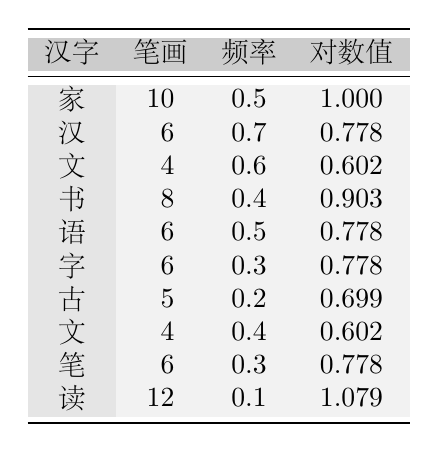What is the stroke count for the character "家"? The table lists the character "家" with a stroke count of 10 in the corresponding row.
Answer: 10 How many characters have a stroke count of 6? By examining the table, the characters "汉," "语," "字," and "笔" have a stroke count of 6. This makes a total of 4 characters.
Answer: 4 Is the frequency of the character "书" greater than 0.5? The table indicates that the frequency for "书" is 0.4, which is less than 0.5.
Answer: No What is the character with the highest stroke count? Comparing the stroke counts across the table, "读" has the highest stroke count of 12.
Answer: 读 What is the average stroke count of the characters listed in the table? To find the average, we sum all stroke counts: 10 + 6 + 4 + 8 + 6 + 6 + 5 + 4 + 6 + 12 = 57. There are 10 characters, so the average is 57 / 10 = 5.7.
Answer: 5.7 Which character has the lowest frequency, and what is that frequency? By reviewing the frequencies in the table, "读" holds the lowest frequency at 0.1.
Answer: 读, 0.1 Is it true that every character with a stroke count of 6 has the same log value? The characters with a stroke count of 6 are "汉," "语," "字," and "笔," but their log values differ (0.778 for all). Thus, the statement is true.
Answer: Yes What is the difference between the stroke count of "读" and "家"? The stroke count for "读" is 12 and for "家" is 10. The difference is 12 - 10 = 2.
Answer: 2 What is the total log value of all characters in the table? The log values are: 1.0 + 0.778 + 0.602 + 0.903 + 0.778 + 0.778 + 0.699 + 0.602 + 0.778 + 1.079 = 7.497. The total log value is therefore 7.497.
Answer: 7.497 